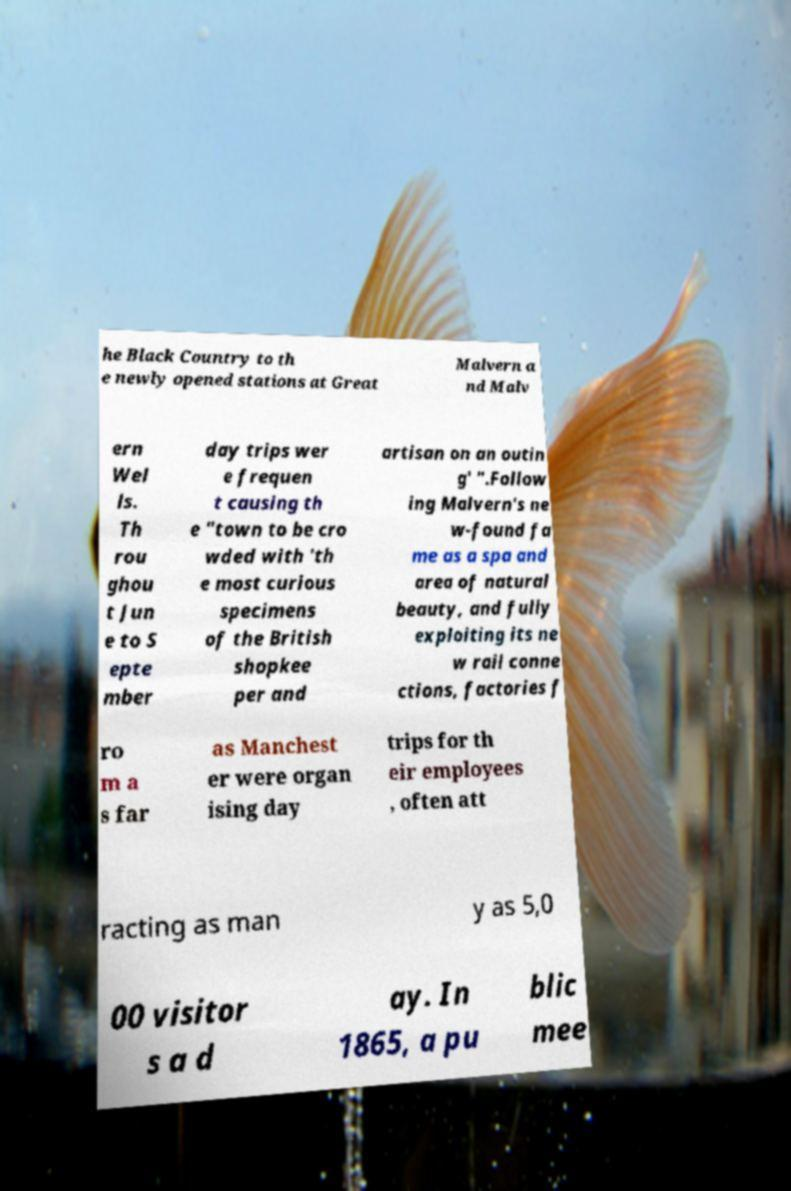Can you accurately transcribe the text from the provided image for me? he Black Country to th e newly opened stations at Great Malvern a nd Malv ern Wel ls. Th rou ghou t Jun e to S epte mber day trips wer e frequen t causing th e "town to be cro wded with 'th e most curious specimens of the British shopkee per and artisan on an outin g' ".Follow ing Malvern's ne w-found fa me as a spa and area of natural beauty, and fully exploiting its ne w rail conne ctions, factories f ro m a s far as Manchest er were organ ising day trips for th eir employees , often att racting as man y as 5,0 00 visitor s a d ay. In 1865, a pu blic mee 